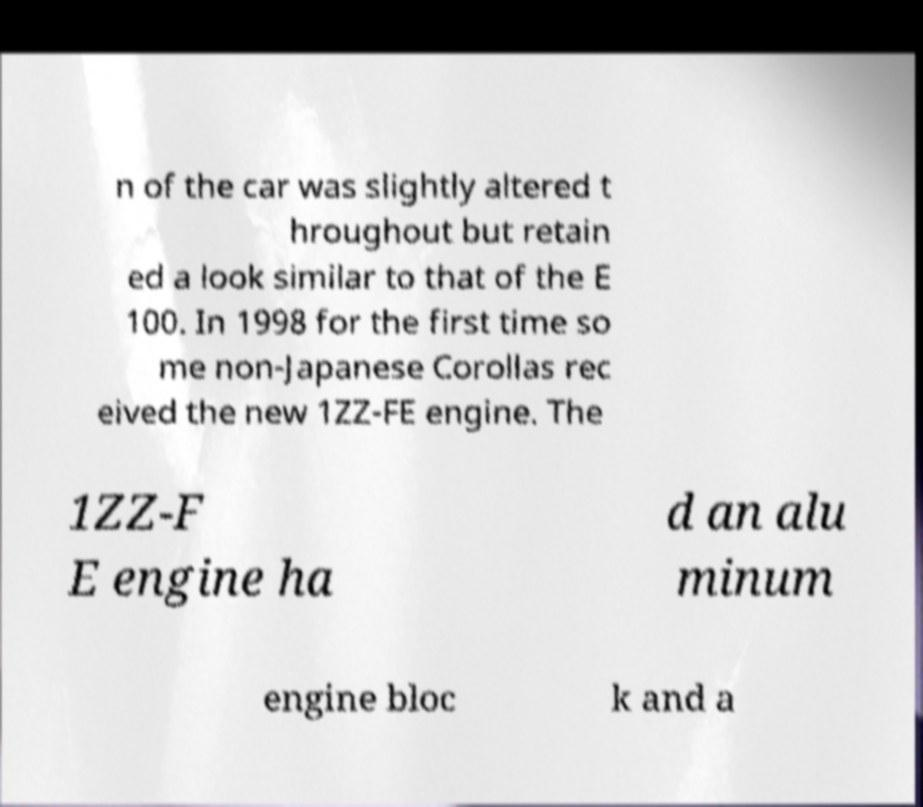There's text embedded in this image that I need extracted. Can you transcribe it verbatim? n of the car was slightly altered t hroughout but retain ed a look similar to that of the E 100. In 1998 for the first time so me non-Japanese Corollas rec eived the new 1ZZ-FE engine. The 1ZZ-F E engine ha d an alu minum engine bloc k and a 